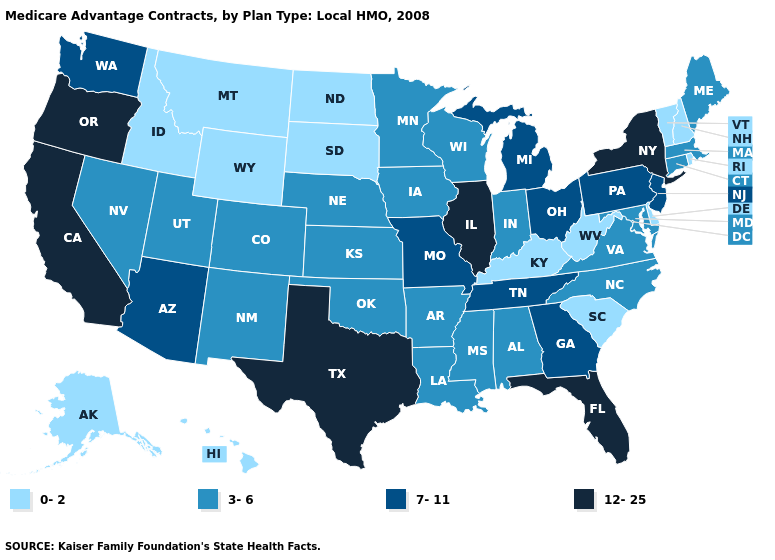Among the states that border Mississippi , which have the lowest value?
Answer briefly. Alabama, Arkansas, Louisiana. What is the lowest value in the West?
Be succinct. 0-2. Does the map have missing data?
Be succinct. No. What is the value of Missouri?
Keep it brief. 7-11. Does the first symbol in the legend represent the smallest category?
Be succinct. Yes. Name the states that have a value in the range 3-6?
Short answer required. Alabama, Arkansas, Colorado, Connecticut, Iowa, Indiana, Kansas, Louisiana, Massachusetts, Maryland, Maine, Minnesota, Mississippi, North Carolina, Nebraska, New Mexico, Nevada, Oklahoma, Utah, Virginia, Wisconsin. Among the states that border Oklahoma , which have the lowest value?
Give a very brief answer. Arkansas, Colorado, Kansas, New Mexico. Among the states that border Delaware , does New Jersey have the lowest value?
Answer briefly. No. Does the map have missing data?
Answer briefly. No. How many symbols are there in the legend?
Quick response, please. 4. What is the highest value in states that border Georgia?
Concise answer only. 12-25. Among the states that border Oregon , does Washington have the highest value?
Give a very brief answer. No. What is the value of Illinois?
Concise answer only. 12-25. Does the map have missing data?
Keep it brief. No. Name the states that have a value in the range 12-25?
Concise answer only. California, Florida, Illinois, New York, Oregon, Texas. 